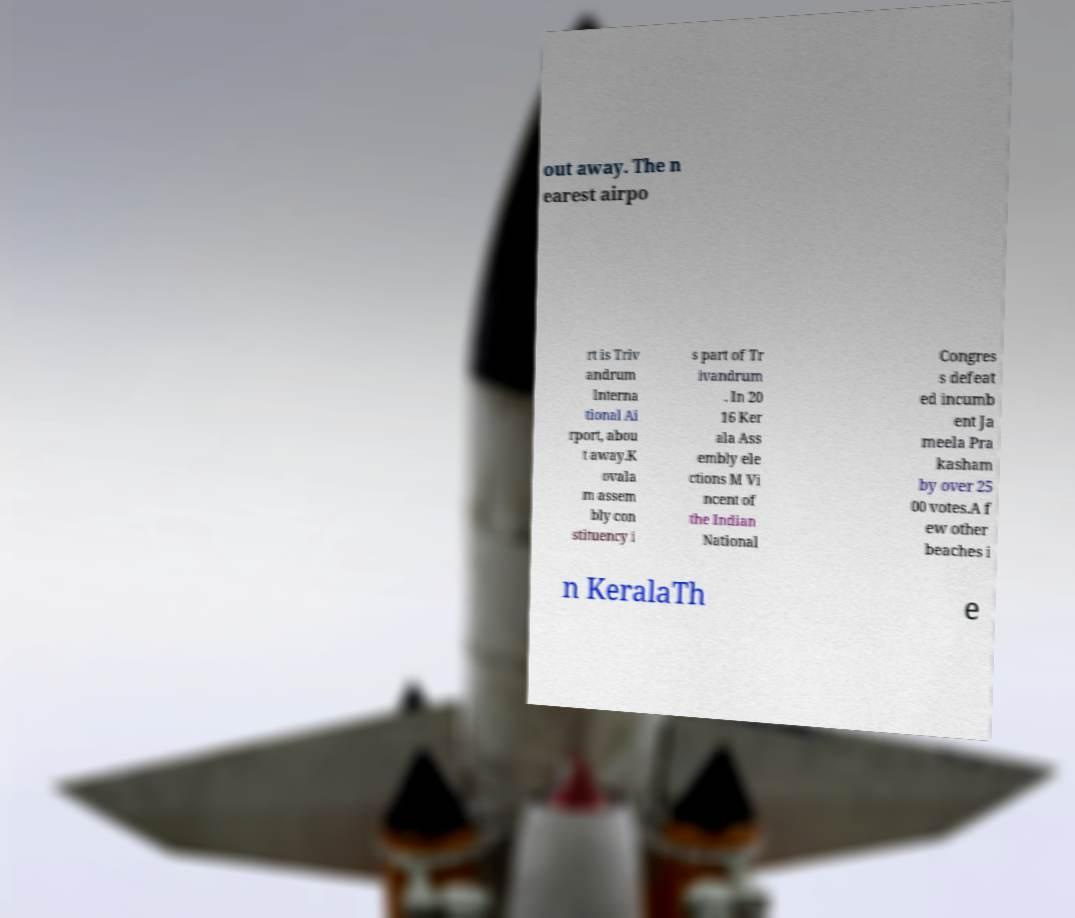There's text embedded in this image that I need extracted. Can you transcribe it verbatim? out away. The n earest airpo rt is Triv andrum Interna tional Ai rport, abou t away.K ovala m assem bly con stituency i s part of Tr ivandrum . In 20 16 Ker ala Ass embly ele ctions M Vi ncent of the Indian National Congres s defeat ed incumb ent Ja meela Pra kasham by over 25 00 votes.A f ew other beaches i n KeralaTh e 